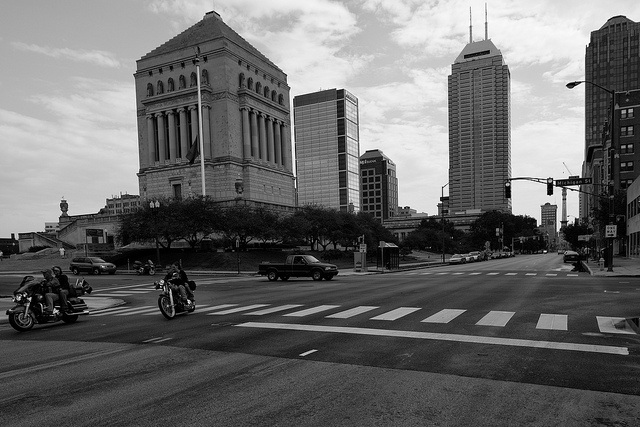<image>What city is this in? I don't know what city this is in. It could be Bristol, Washington DC, New York, Salt Lake City, or Dublin. What city is this in? I am not sure what city this is in. It can be either Bristol, Washington DC, New York, Salt Lake City, or Dublin. 